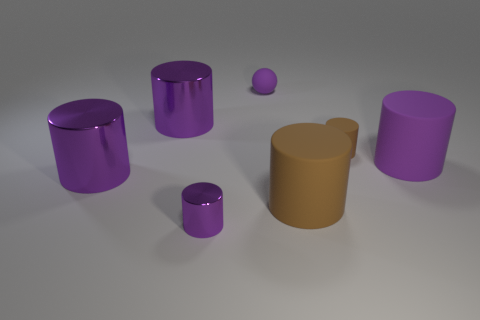There is a purple rubber sphere; does it have the same size as the purple thing that is right of the small purple matte ball?
Your answer should be very brief. No. How many shiny things are either purple cylinders or large blue cylinders?
Ensure brevity in your answer.  3. Are there any other things that have the same material as the small brown object?
Give a very brief answer. Yes. Is the color of the matte ball the same as the small object that is in front of the large purple rubber cylinder?
Your answer should be very brief. Yes. The big brown thing is what shape?
Give a very brief answer. Cylinder. There is a shiny cylinder that is left of the large object that is behind the purple rubber thing on the right side of the purple ball; what is its size?
Your answer should be compact. Large. How many other things are the same shape as the large purple matte thing?
Give a very brief answer. 5. There is a brown matte thing that is behind the big purple matte thing; is it the same shape as the tiny purple rubber thing that is on the left side of the tiny brown matte cylinder?
Your answer should be very brief. No. How many cylinders are yellow objects or big rubber things?
Offer a very short reply. 2. What material is the small object that is behind the large purple metal object that is behind the purple cylinder that is on the right side of the small purple sphere made of?
Your answer should be very brief. Rubber. 